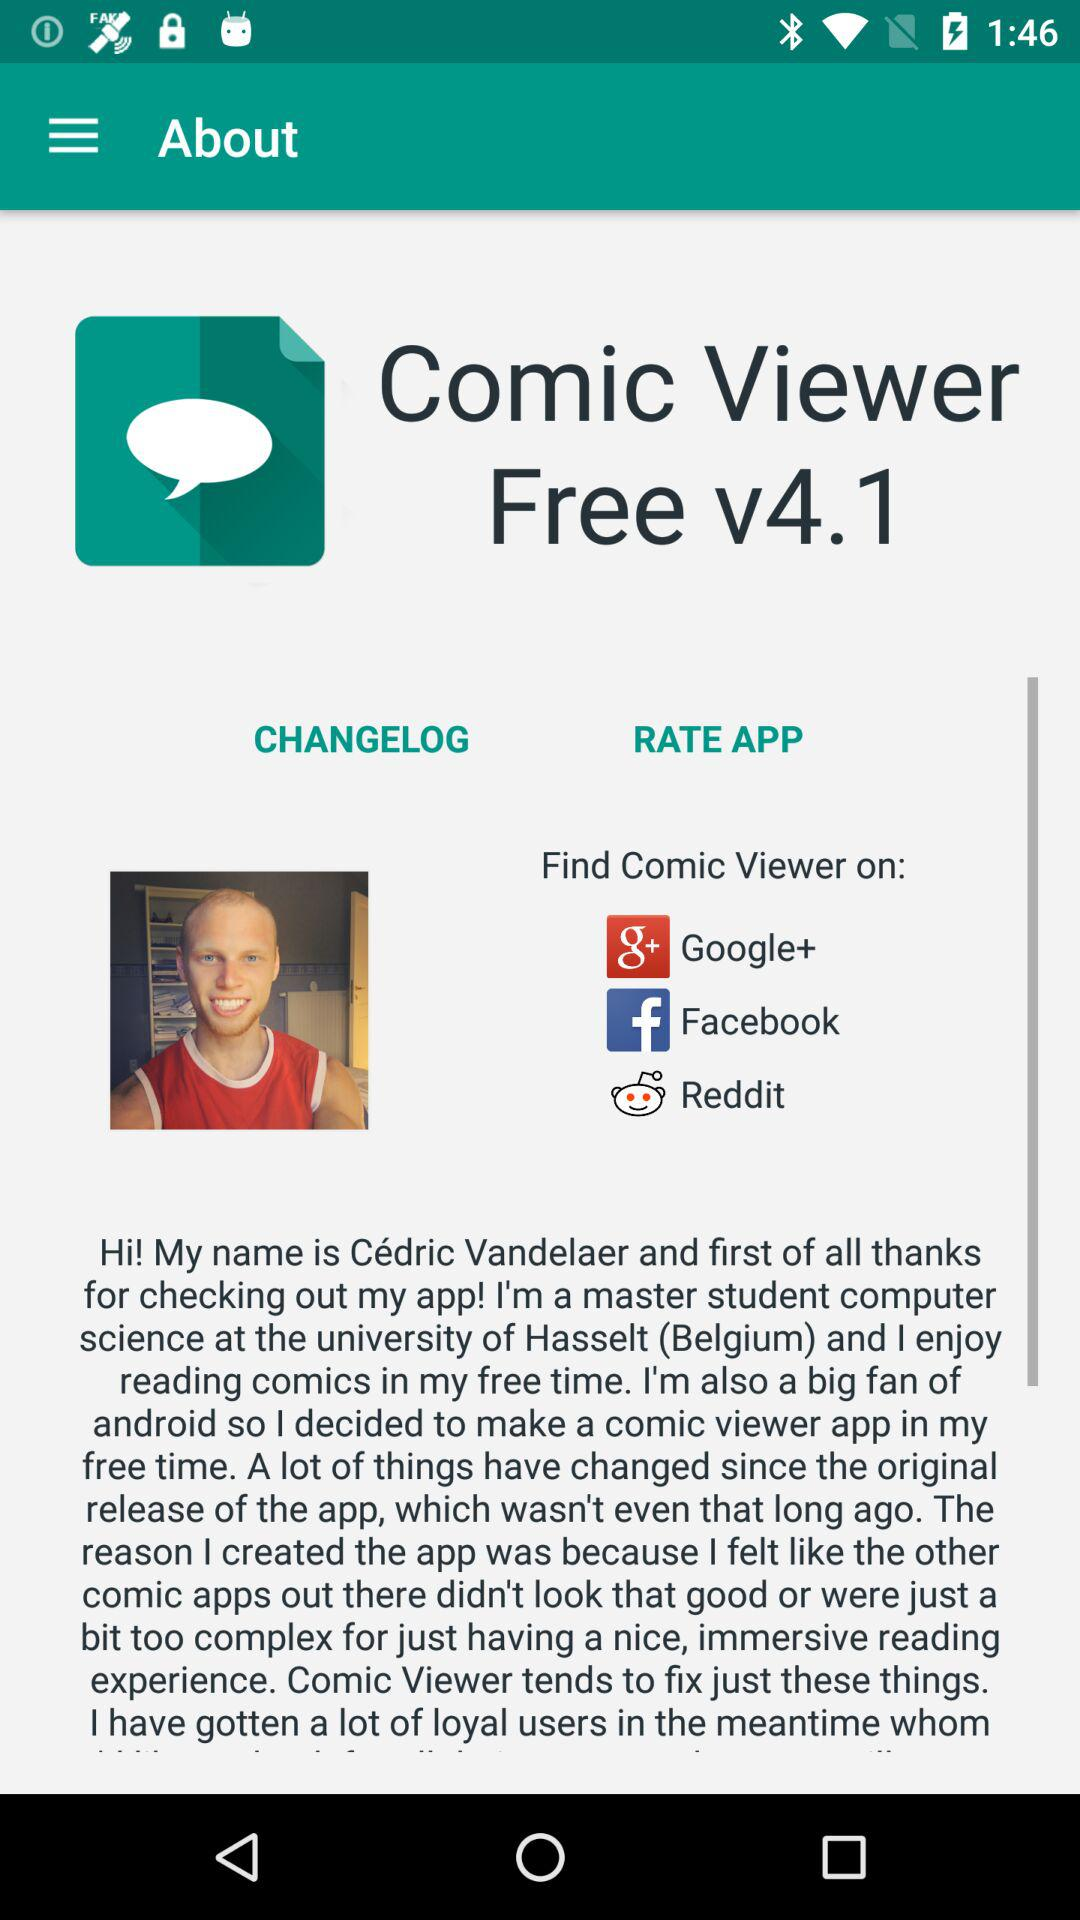Which applications are used to find more viewer? To increase viewer engagement for apps like the one shown in the image, social media platforms such as Google+, Facebook, and Reddit can be very effective. These platforms allow developers to reach a broad audience, promote features interactively, and gather user feedback. Additionally, integrating social sharing within the app can motivate current users to invite their connections, potentially increasing the viewer base organically. 